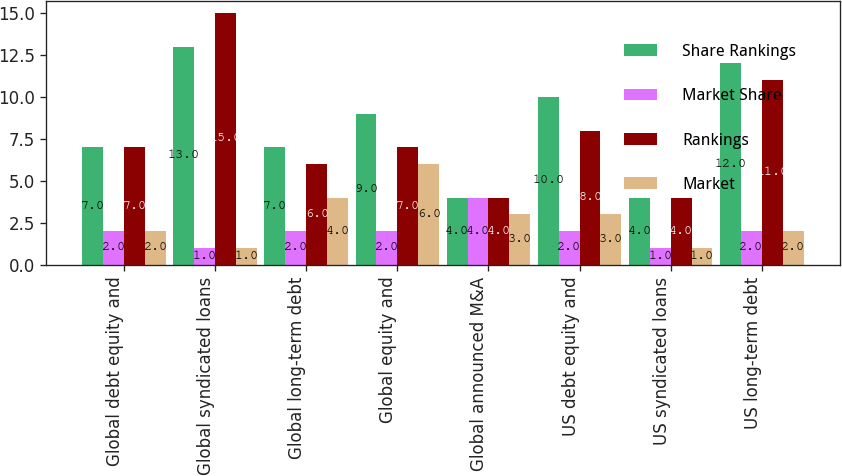Convert chart to OTSL. <chart><loc_0><loc_0><loc_500><loc_500><stacked_bar_chart><ecel><fcel>Global debt equity and<fcel>Global syndicated loans<fcel>Global long-term debt<fcel>Global equity and<fcel>Global announced M&A<fcel>US debt equity and<fcel>US syndicated loans<fcel>US long-term debt<nl><fcel>Share Rankings<fcel>7<fcel>13<fcel>7<fcel>9<fcel>4<fcel>10<fcel>4<fcel>12<nl><fcel>Market Share<fcel>2<fcel>1<fcel>2<fcel>2<fcel>4<fcel>2<fcel>1<fcel>2<nl><fcel>Rankings<fcel>7<fcel>15<fcel>6<fcel>7<fcel>4<fcel>8<fcel>4<fcel>11<nl><fcel>Market<fcel>2<fcel>1<fcel>4<fcel>6<fcel>3<fcel>3<fcel>1<fcel>2<nl></chart> 